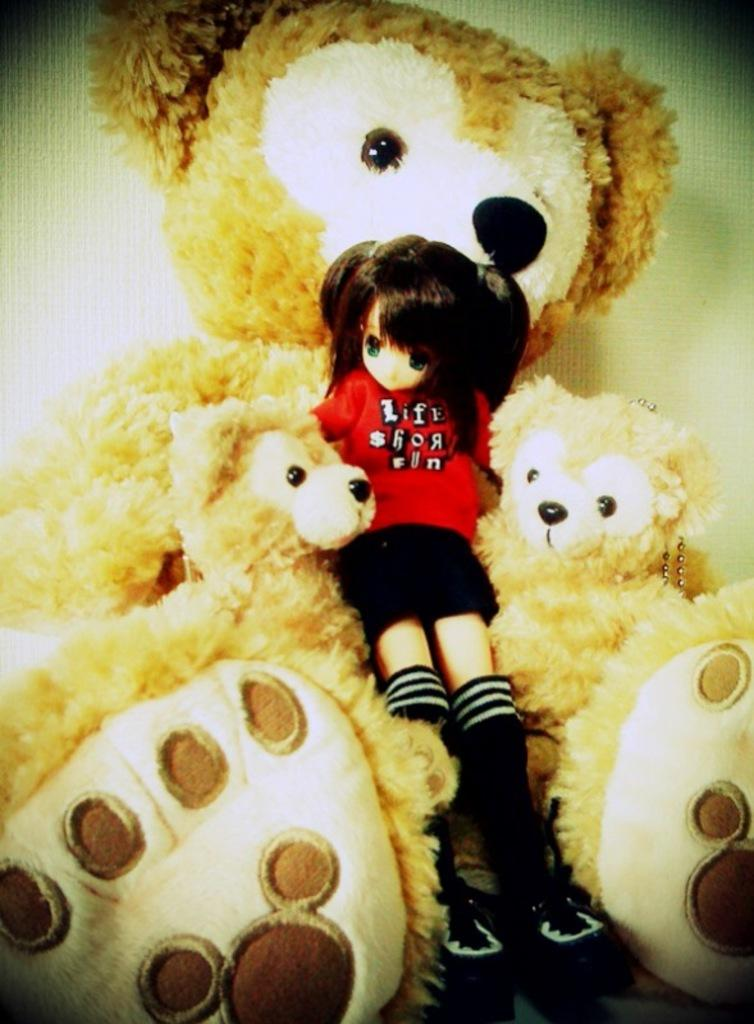How many teddy bears are present in the image? There are 3 teddy bears in the image. What other type of toy can be seen in the image? There is a doll in the image. How does the passenger rub the effect of the teddy bears in the image? There is no passenger or rubbing of any effect in the image; it only features teddy bears and a doll. 